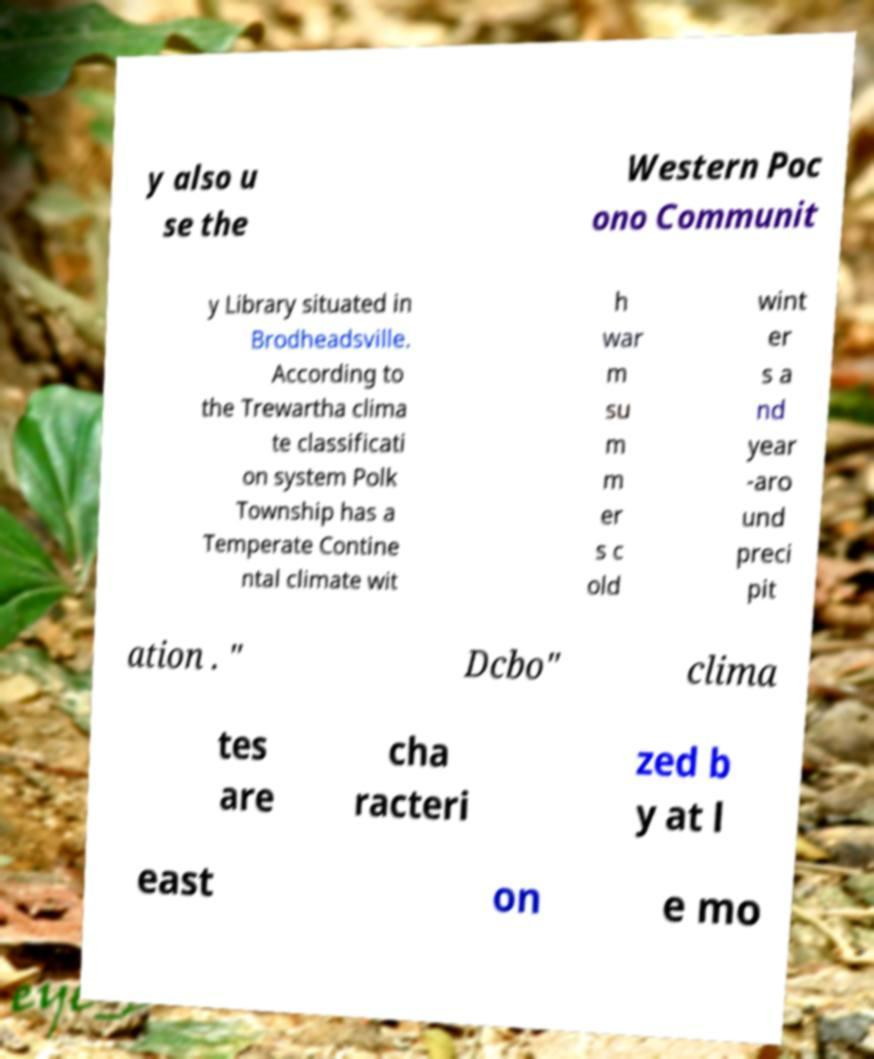For documentation purposes, I need the text within this image transcribed. Could you provide that? y also u se the Western Poc ono Communit y Library situated in Brodheadsville. According to the Trewartha clima te classificati on system Polk Township has a Temperate Contine ntal climate wit h war m su m m er s c old wint er s a nd year -aro und preci pit ation . " Dcbo" clima tes are cha racteri zed b y at l east on e mo 